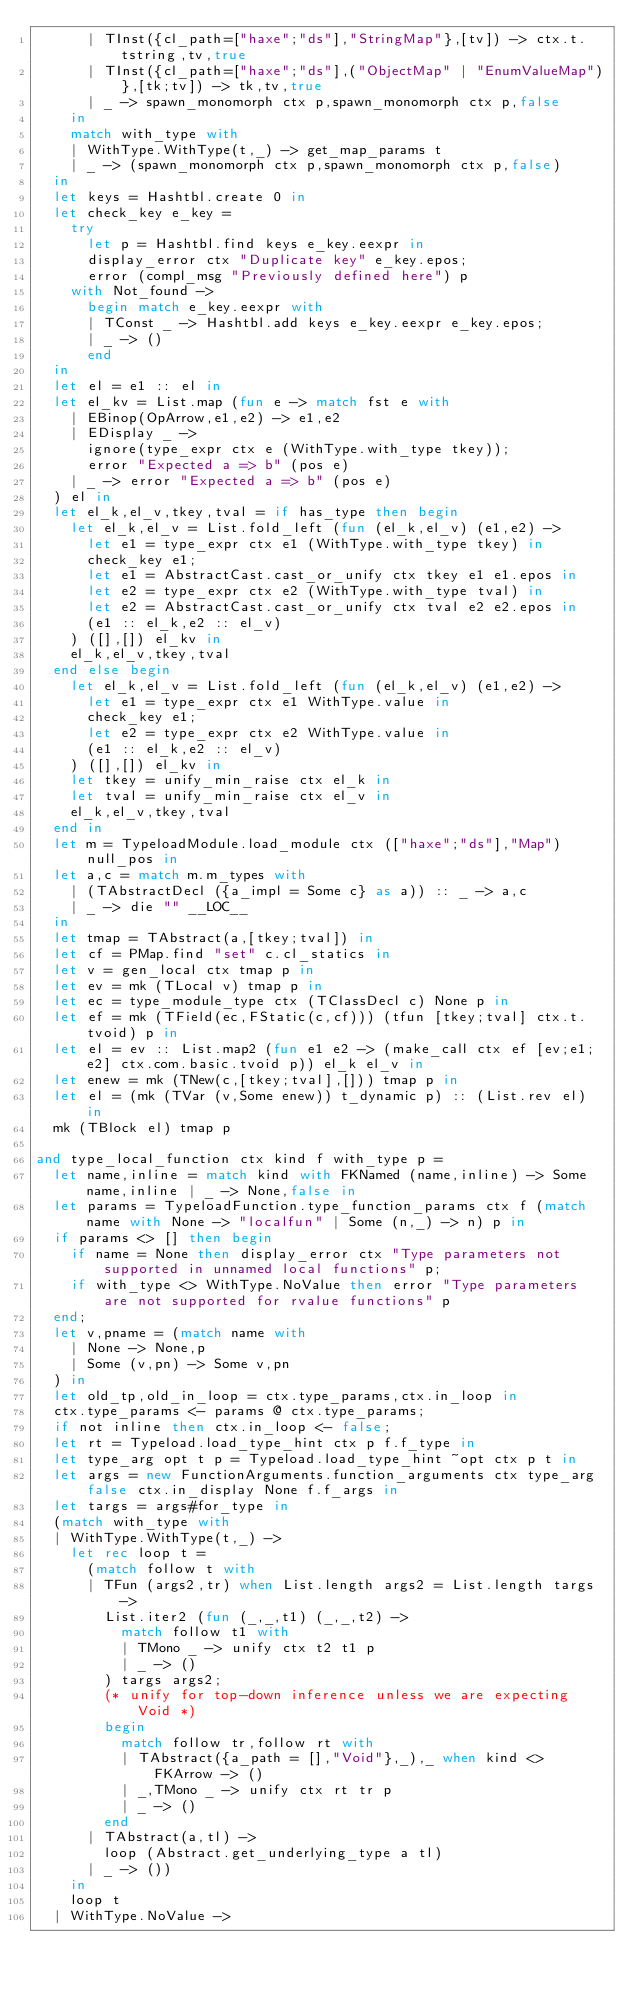Convert code to text. <code><loc_0><loc_0><loc_500><loc_500><_OCaml_>			| TInst({cl_path=["haxe";"ds"],"StringMap"},[tv]) -> ctx.t.tstring,tv,true
			| TInst({cl_path=["haxe";"ds"],("ObjectMap" | "EnumValueMap")},[tk;tv]) -> tk,tv,true
			| _ -> spawn_monomorph ctx p,spawn_monomorph ctx p,false
		in
		match with_type with
		| WithType.WithType(t,_) -> get_map_params t
		| _ -> (spawn_monomorph ctx p,spawn_monomorph ctx p,false)
	in
	let keys = Hashtbl.create 0 in
	let check_key e_key =
		try
			let p = Hashtbl.find keys e_key.eexpr in
			display_error ctx "Duplicate key" e_key.epos;
			error (compl_msg "Previously defined here") p
		with Not_found ->
			begin match e_key.eexpr with
			| TConst _ -> Hashtbl.add keys e_key.eexpr e_key.epos;
			| _ -> ()
			end
	in
	let el = e1 :: el in
	let el_kv = List.map (fun e -> match fst e with
		| EBinop(OpArrow,e1,e2) -> e1,e2
		| EDisplay _ ->
			ignore(type_expr ctx e (WithType.with_type tkey));
			error "Expected a => b" (pos e)
		| _ -> error "Expected a => b" (pos e)
	) el in
	let el_k,el_v,tkey,tval = if has_type then begin
		let el_k,el_v = List.fold_left (fun (el_k,el_v) (e1,e2) ->
			let e1 = type_expr ctx e1 (WithType.with_type tkey) in
			check_key e1;
			let e1 = AbstractCast.cast_or_unify ctx tkey e1 e1.epos in
			let e2 = type_expr ctx e2 (WithType.with_type tval) in
			let e2 = AbstractCast.cast_or_unify ctx tval e2 e2.epos in
			(e1 :: el_k,e2 :: el_v)
		) ([],[]) el_kv in
		el_k,el_v,tkey,tval
	end else begin
		let el_k,el_v = List.fold_left (fun (el_k,el_v) (e1,e2) ->
			let e1 = type_expr ctx e1 WithType.value in
			check_key e1;
			let e2 = type_expr ctx e2 WithType.value in
			(e1 :: el_k,e2 :: el_v)
		) ([],[]) el_kv in
		let tkey = unify_min_raise ctx el_k in
		let tval = unify_min_raise ctx el_v in
		el_k,el_v,tkey,tval
	end in
	let m = TypeloadModule.load_module ctx (["haxe";"ds"],"Map") null_pos in
	let a,c = match m.m_types with
		| (TAbstractDecl ({a_impl = Some c} as a)) :: _ -> a,c
		| _ -> die "" __LOC__
	in
	let tmap = TAbstract(a,[tkey;tval]) in
	let cf = PMap.find "set" c.cl_statics in
	let v = gen_local ctx tmap p in
	let ev = mk (TLocal v) tmap p in
	let ec = type_module_type ctx (TClassDecl c) None p in
	let ef = mk (TField(ec,FStatic(c,cf))) (tfun [tkey;tval] ctx.t.tvoid) p in
	let el = ev :: List.map2 (fun e1 e2 -> (make_call ctx ef [ev;e1;e2] ctx.com.basic.tvoid p)) el_k el_v in
	let enew = mk (TNew(c,[tkey;tval],[])) tmap p in
	let el = (mk (TVar (v,Some enew)) t_dynamic p) :: (List.rev el) in
	mk (TBlock el) tmap p

and type_local_function ctx kind f with_type p =
	let name,inline = match kind with FKNamed (name,inline) -> Some name,inline | _ -> None,false in
	let params = TypeloadFunction.type_function_params ctx f (match name with None -> "localfun" | Some (n,_) -> n) p in
	if params <> [] then begin
		if name = None then display_error ctx "Type parameters not supported in unnamed local functions" p;
		if with_type <> WithType.NoValue then error "Type parameters are not supported for rvalue functions" p
	end;
	let v,pname = (match name with
		| None -> None,p
		| Some (v,pn) -> Some v,pn
	) in
	let old_tp,old_in_loop = ctx.type_params,ctx.in_loop in
	ctx.type_params <- params @ ctx.type_params;
	if not inline then ctx.in_loop <- false;
	let rt = Typeload.load_type_hint ctx p f.f_type in
	let type_arg opt t p = Typeload.load_type_hint ~opt ctx p t in
	let args = new FunctionArguments.function_arguments ctx type_arg false ctx.in_display None f.f_args in
	let targs = args#for_type in
	(match with_type with
	| WithType.WithType(t,_) ->
		let rec loop t =
			(match follow t with
			| TFun (args2,tr) when List.length args2 = List.length targs ->
				List.iter2 (fun (_,_,t1) (_,_,t2) ->
					match follow t1 with
					| TMono _ -> unify ctx t2 t1 p
					| _ -> ()
				) targs args2;
				(* unify for top-down inference unless we are expecting Void *)
				begin
					match follow tr,follow rt with
					| TAbstract({a_path = [],"Void"},_),_ when kind <> FKArrow -> ()
					| _,TMono _ -> unify ctx rt tr p
					| _ -> ()
				end
			| TAbstract(a,tl) ->
				loop (Abstract.get_underlying_type a tl)
			| _ -> ())
		in
		loop t
	| WithType.NoValue -></code> 